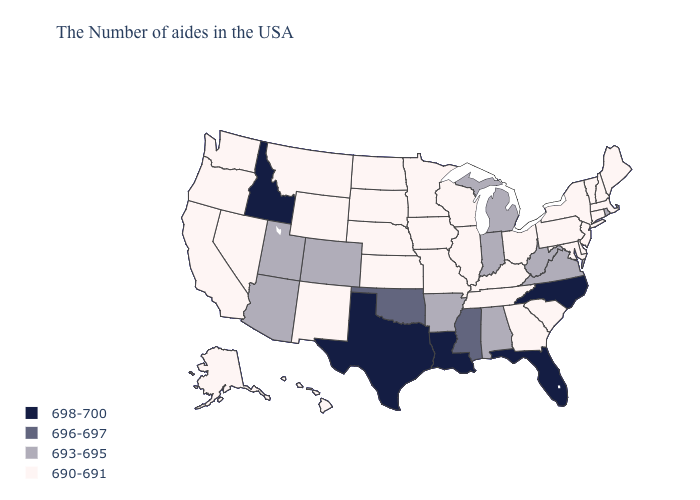Does Michigan have the same value as North Carolina?
Be succinct. No. Does Washington have the same value as Illinois?
Quick response, please. Yes. What is the highest value in states that border New Hampshire?
Give a very brief answer. 690-691. What is the value of North Dakota?
Keep it brief. 690-691. Does California have the same value as Colorado?
Quick response, please. No. Name the states that have a value in the range 690-691?
Answer briefly. Maine, Massachusetts, New Hampshire, Vermont, Connecticut, New York, New Jersey, Delaware, Maryland, Pennsylvania, South Carolina, Ohio, Georgia, Kentucky, Tennessee, Wisconsin, Illinois, Missouri, Minnesota, Iowa, Kansas, Nebraska, South Dakota, North Dakota, Wyoming, New Mexico, Montana, Nevada, California, Washington, Oregon, Alaska, Hawaii. Does the first symbol in the legend represent the smallest category?
Give a very brief answer. No. What is the highest value in the MidWest ?
Keep it brief. 693-695. Does New Hampshire have a higher value than Maine?
Give a very brief answer. No. Does Texas have the same value as Idaho?
Be succinct. Yes. Among the states that border Idaho , does Utah have the highest value?
Give a very brief answer. Yes. Name the states that have a value in the range 698-700?
Write a very short answer. North Carolina, Florida, Louisiana, Texas, Idaho. What is the lowest value in the USA?
Answer briefly. 690-691. Is the legend a continuous bar?
Keep it brief. No. 